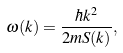Convert formula to latex. <formula><loc_0><loc_0><loc_500><loc_500>\omega ( k ) = \frac { \hbar { k } ^ { 2 } } { 2 m S ( k ) } ,</formula> 